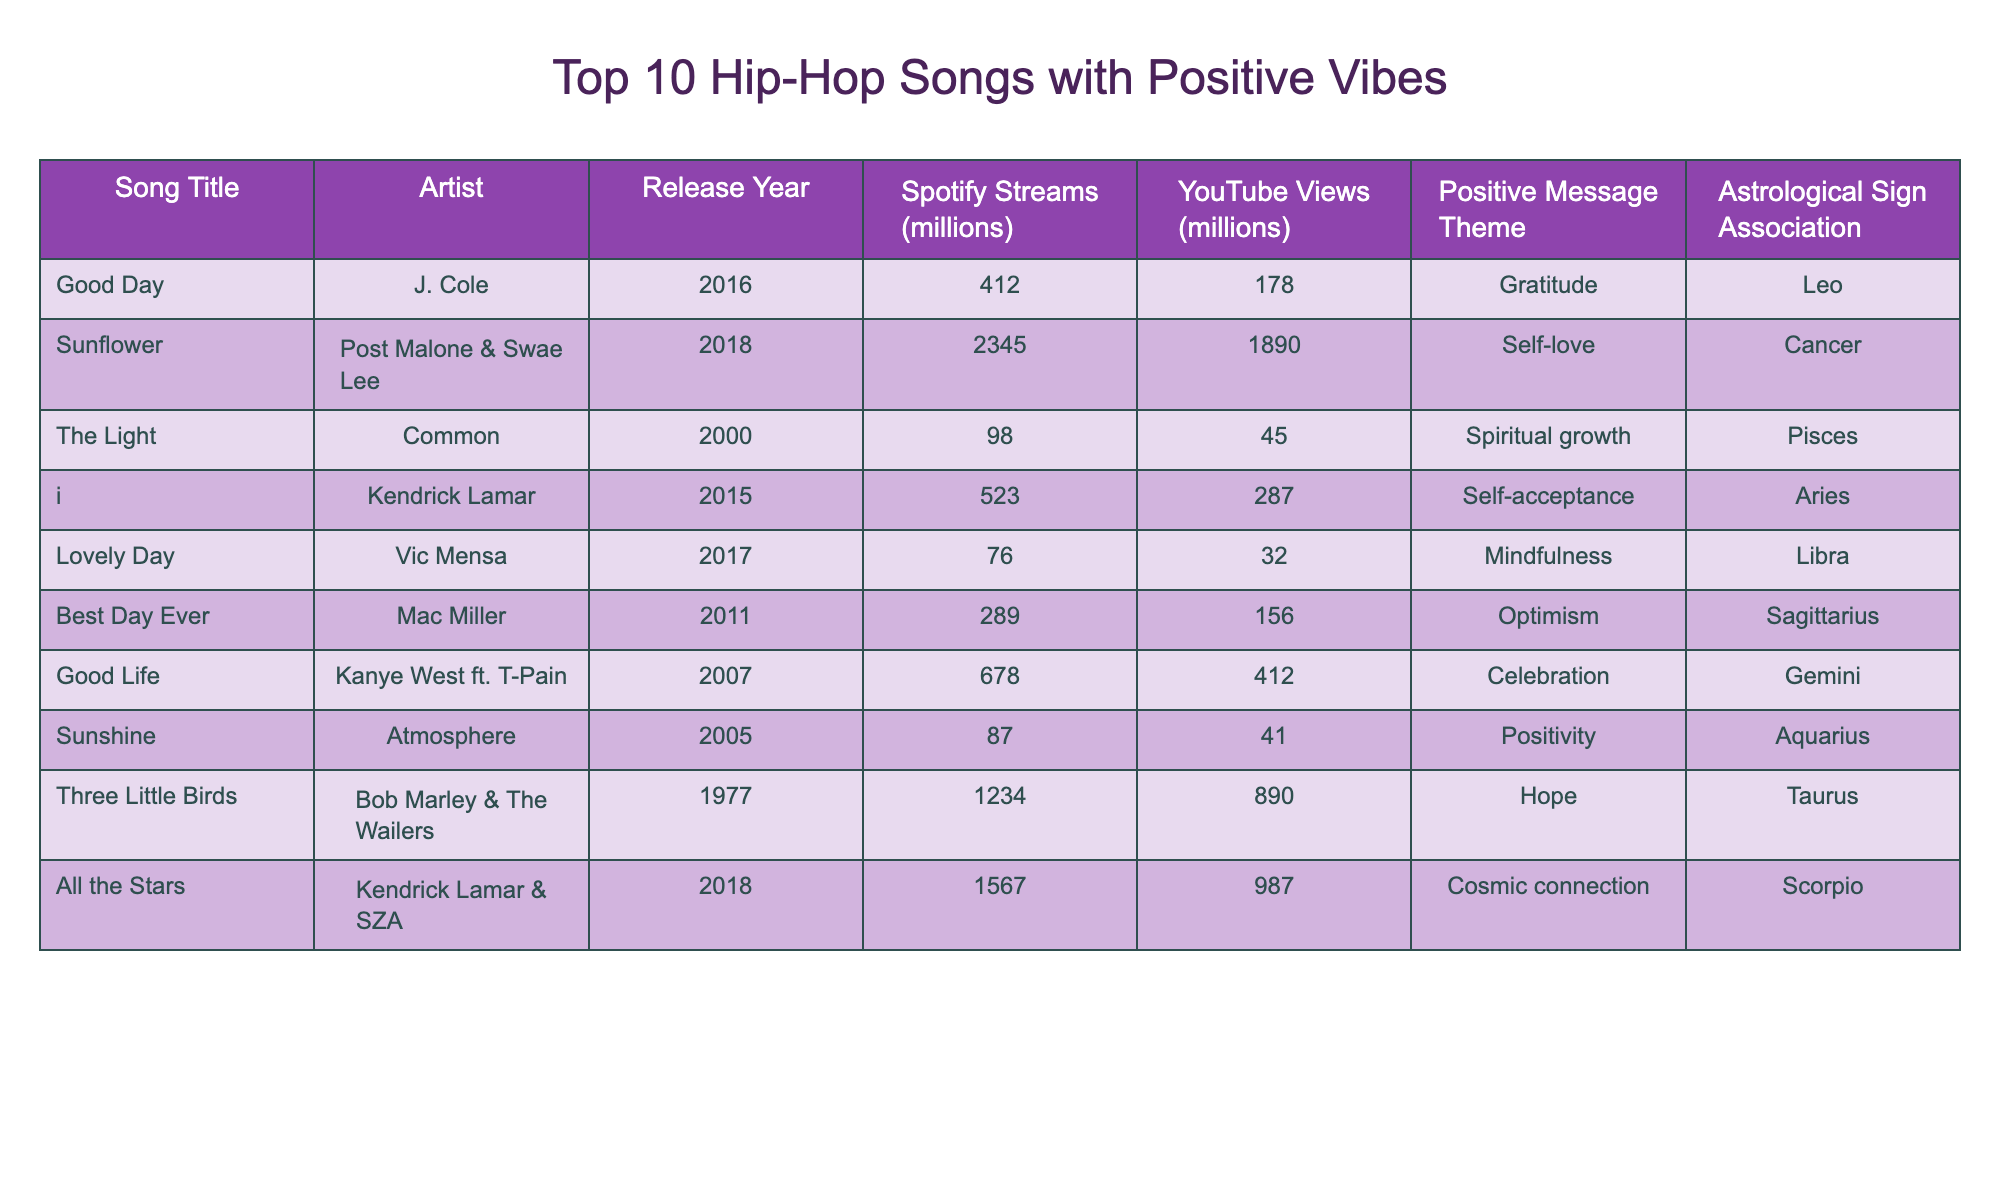What is the song with the highest Spotify streams? By looking at the Spotify Streams column, "Sunflower" by Post Malone & Swae Lee has the highest number at 2345 million streams.
Answer: Sunflower Which artist has a song associated with the theme of self-acceptance? The song "i" by Kendrick Lamar is listed with the positive message theme of self-acceptance.
Answer: Kendrick Lamar What is the average number of Spotify streams for the songs listed? To find the average, first sum the Spotify streams: 412 + 2345 + 98 + 523 + 76 + 289 + 678 + 87 + 1234 + 1567 = 5770. Then divide by the number of songs (10): 5770 / 10 = 577.
Answer: 577 Is there a song associated with the Cancer astrological sign? Yes, "Sunflower" by Post Malone & Swae Lee is associated with the Cancer sign.
Answer: Yes Which song has both a high number of YouTube views and an optimistic message? "All the Stars" by Kendrick Lamar & SZA has 987 million YouTube views and is associated with the theme of cosmic connection, which can be seen as optimistic.
Answer: All the Stars What is the sum of Spotify streams for songs from artists who have a connection to Sagittarius? The only song associated with Sagittarius is "Best Day Ever" by Mac Miller, which has 289 million streams. Thus, the sum is 289.
Answer: 289 How many songs in the table were released after 2015? The songs "Sunflower" (2018), "All the Stars" (2018), and "i" (2015) were released after 2015, resulting in a total of 3 songs.
Answer: 3 Which positive message theme is associated with the song "Good Life"? "Good Life" by Kanye West ft. T-Pain is associated with the theme of celebration.
Answer: Celebration Can you find a song related to Taurus? "Three Little Birds" by Bob Marley & The Wailers is associated with the Taurus astrological sign.
Answer: Yes What is the difference between the Spotify streams of "Good Day" and "Lovely Day"? "Good Day" has 412 million streams while "Lovely Day" has 76 million streams. The difference is 412 - 76 = 336 million streams.
Answer: 336 